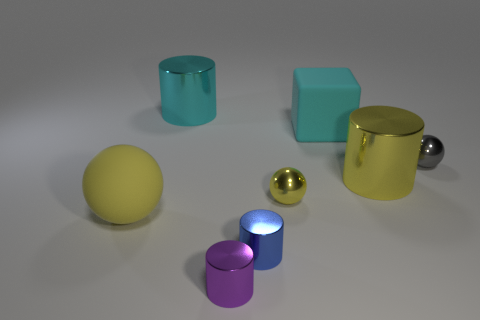Is there any other thing that is the same shape as the cyan rubber thing?
Provide a short and direct response. No. There is a big rubber object that is behind the rubber sphere; what color is it?
Ensure brevity in your answer.  Cyan. Do the large ball and the big metal thing that is to the right of the blue metallic cylinder have the same color?
Provide a succinct answer. Yes. Is the number of yellow metal objects less than the number of purple metal objects?
Ensure brevity in your answer.  No. Does the cylinder to the left of the purple metal cylinder have the same color as the big matte cube?
Give a very brief answer. Yes. What number of cyan cylinders are the same size as the blue thing?
Provide a short and direct response. 0. Are there any things of the same color as the big block?
Your response must be concise. Yes. Is the small purple cylinder made of the same material as the big ball?
Your answer should be compact. No. What number of small blue shiny things are the same shape as the cyan rubber thing?
Your response must be concise. 0. The purple thing that is made of the same material as the tiny blue cylinder is what shape?
Ensure brevity in your answer.  Cylinder. 